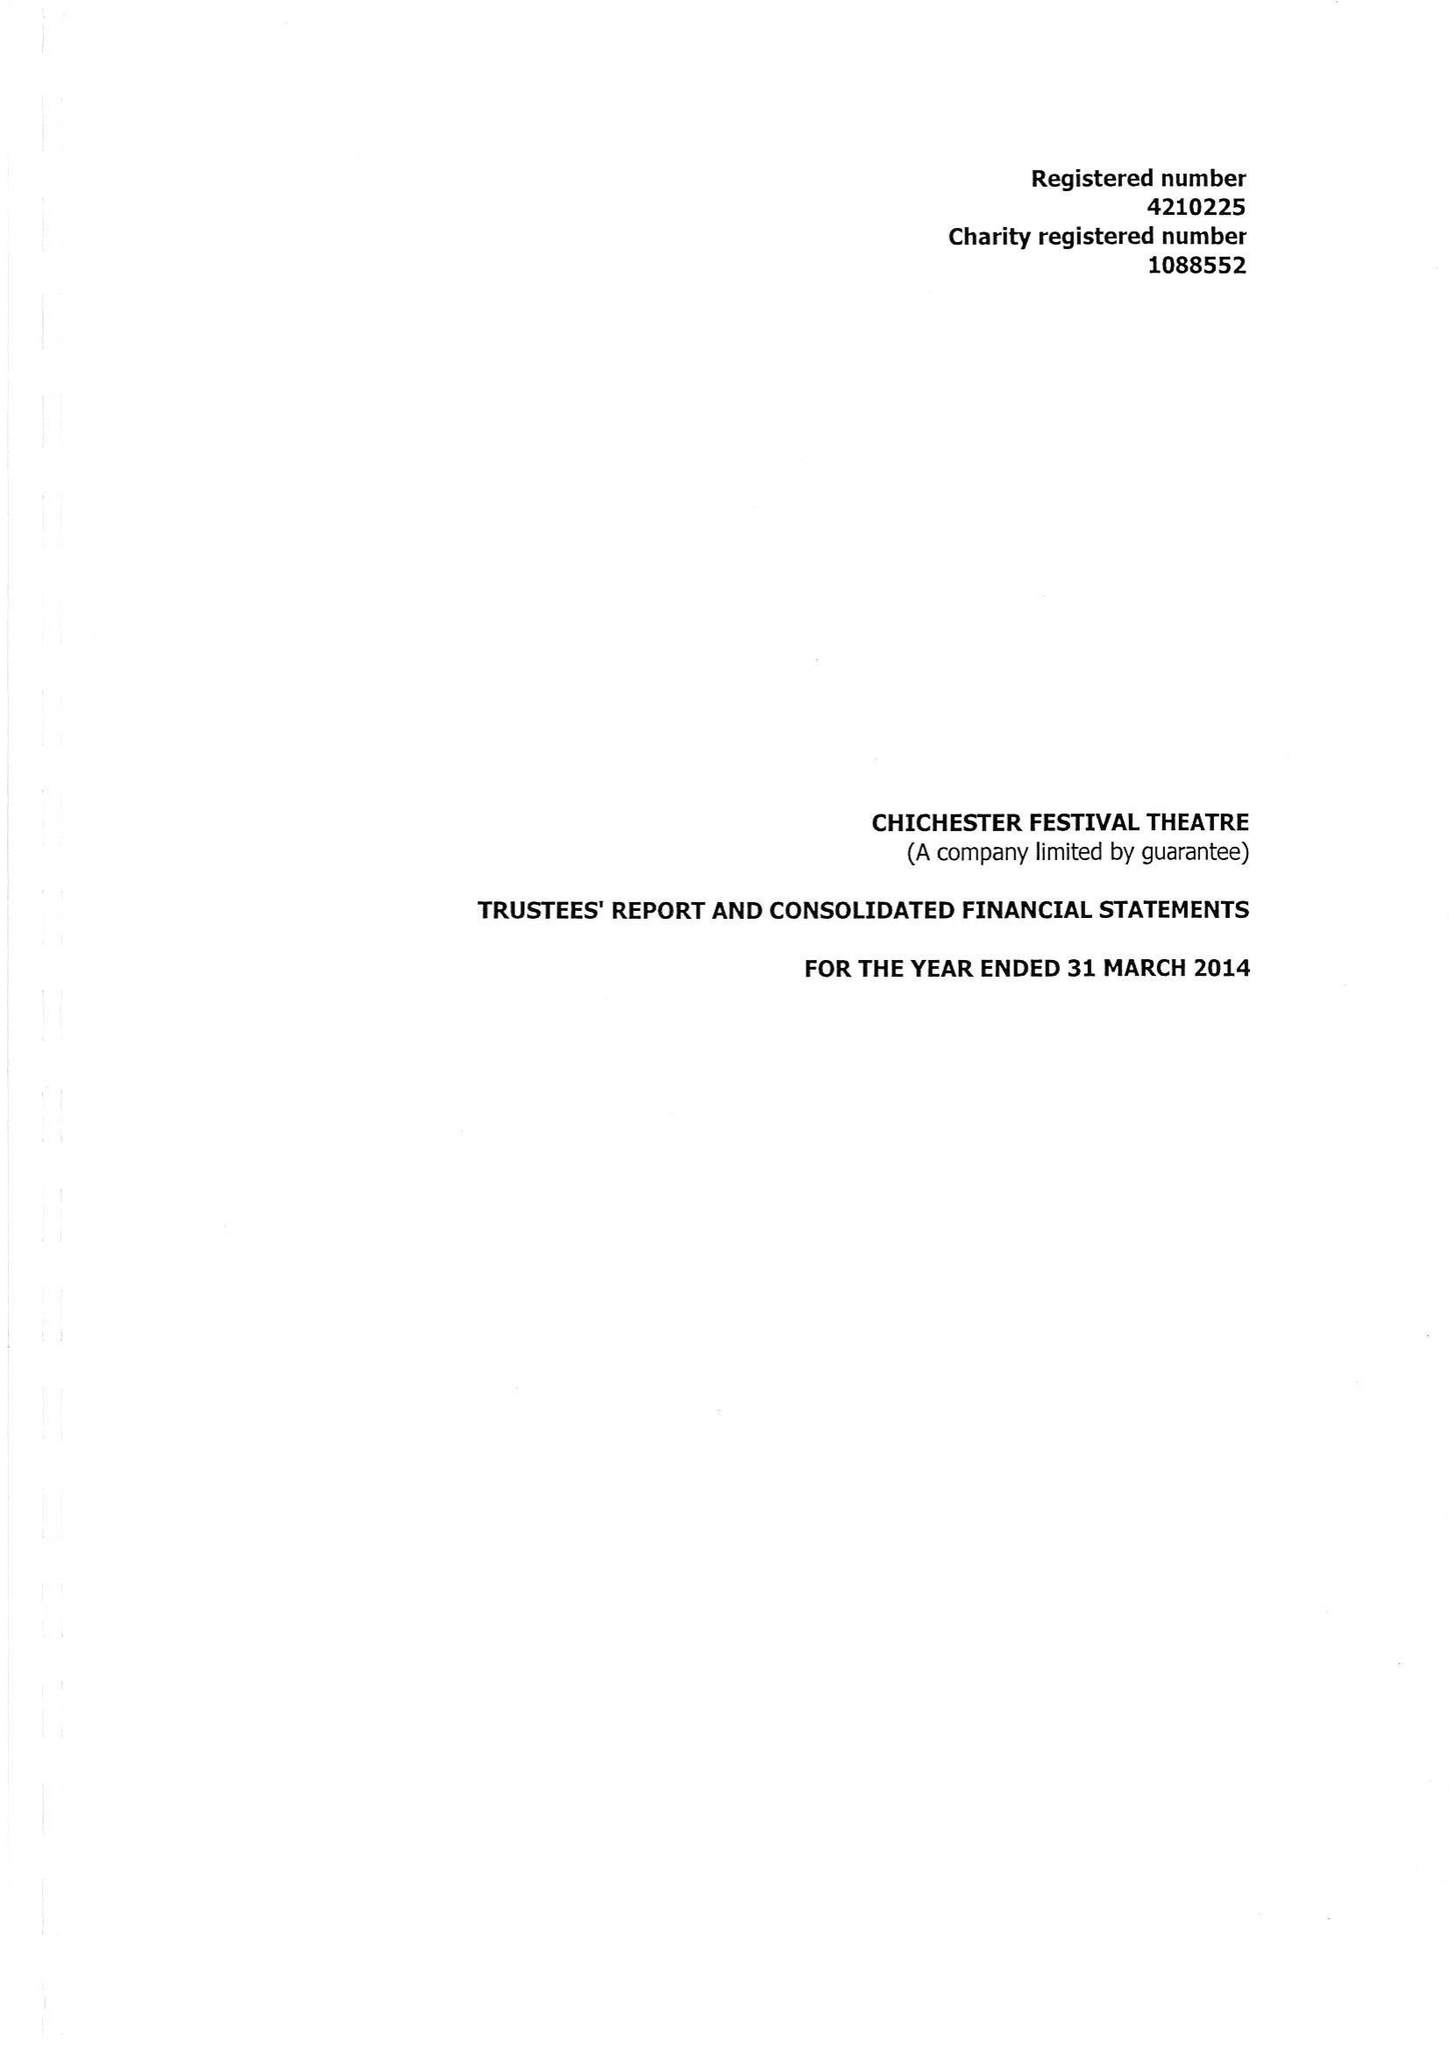What is the value for the address__post_town?
Answer the question using a single word or phrase. CHICHESTER 